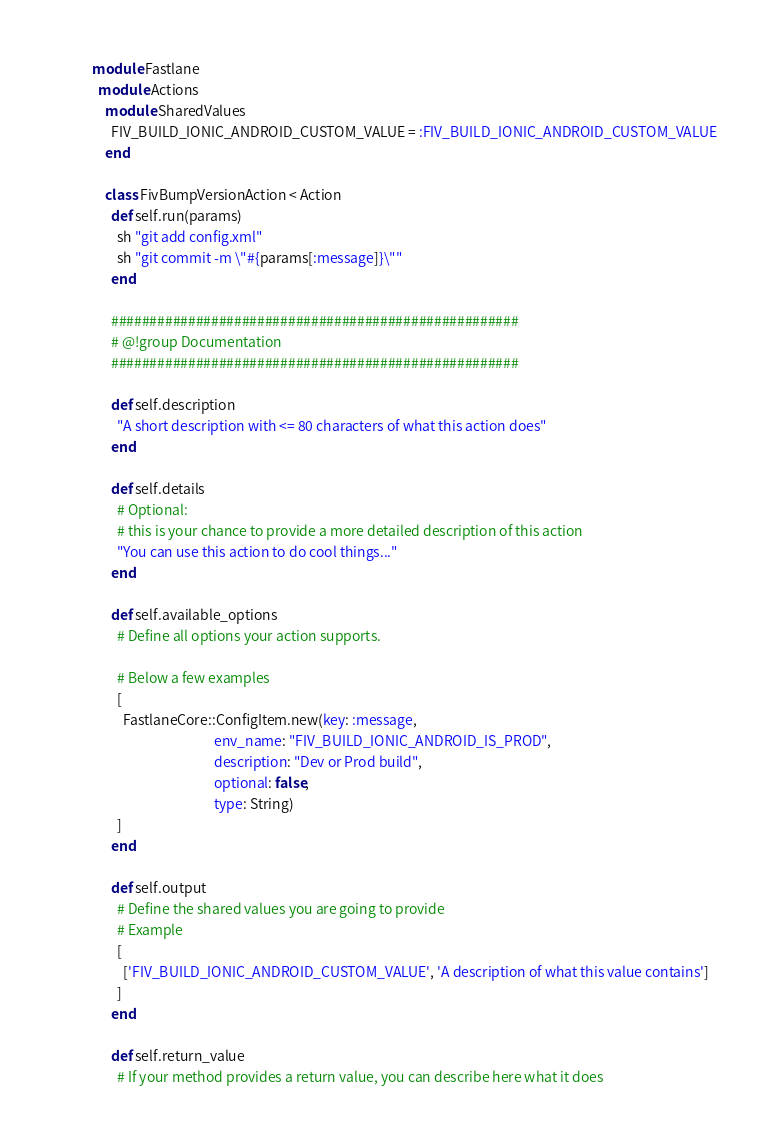Convert code to text. <code><loc_0><loc_0><loc_500><loc_500><_Ruby_>module Fastlane
  module Actions
    module SharedValues
      FIV_BUILD_IONIC_ANDROID_CUSTOM_VALUE = :FIV_BUILD_IONIC_ANDROID_CUSTOM_VALUE
    end

    class FivBumpVersionAction < Action
      def self.run(params)
        sh "git add config.xml"
        sh "git commit -m \"#{params[:message]}\""
      end

      #####################################################
      # @!group Documentation
      #####################################################

      def self.description
        "A short description with <= 80 characters of what this action does"
      end

      def self.details
        # Optional:
        # this is your chance to provide a more detailed description of this action
        "You can use this action to do cool things..."
      end

      def self.available_options
        # Define all options your action supports. 
        
        # Below a few examples
        [
          FastlaneCore::ConfigItem.new(key: :message,
                                       env_name: "FIV_BUILD_IONIC_ANDROID_IS_PROD",
                                       description: "Dev or Prod build",
                                       optional: false,
                                       type: String)
        ]
      end

      def self.output
        # Define the shared values you are going to provide
        # Example
        [
          ['FIV_BUILD_IONIC_ANDROID_CUSTOM_VALUE', 'A description of what this value contains']
        ]
      end

      def self.return_value
        # If your method provides a return value, you can describe here what it does</code> 